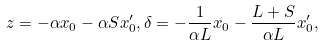Convert formula to latex. <formula><loc_0><loc_0><loc_500><loc_500>z = - \alpha x _ { 0 } - \alpha S x ^ { \prime } _ { 0 } , \delta = - \frac { 1 } { \alpha L } x _ { 0 } - \frac { L + S } { \alpha L } x ^ { \prime } _ { 0 } ,</formula> 